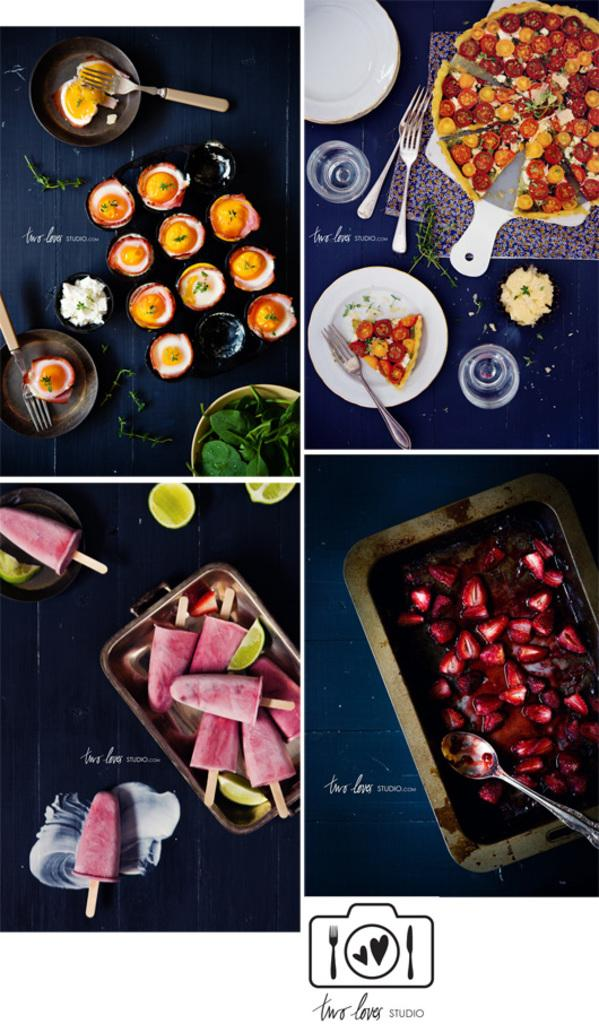What types of food are depicted on the poster? The poster contains images of ice cream, pizza, and fruits. What utensils are featured on the poster? There are forks in the poster. What kitchen item can be seen in the poster? There is a pan in the poster. What is used for serving food in the poster? There is a tray in the poster. Can you see a mountain in the background of the poster? There is no mountain visible in the poster; it contains images of food, utensils, and kitchen items. 